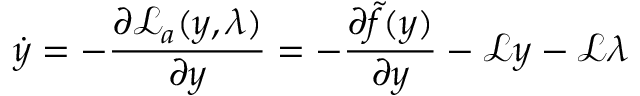Convert formula to latex. <formula><loc_0><loc_0><loc_500><loc_500>\dot { y } = - \frac { \partial \mathcal { L } _ { a } ( y , \lambda ) } { \partial y } = - \frac { \partial \tilde { f } ( y ) } { \partial y } - \mathcal { L } y - \mathcal { L } \lambda</formula> 